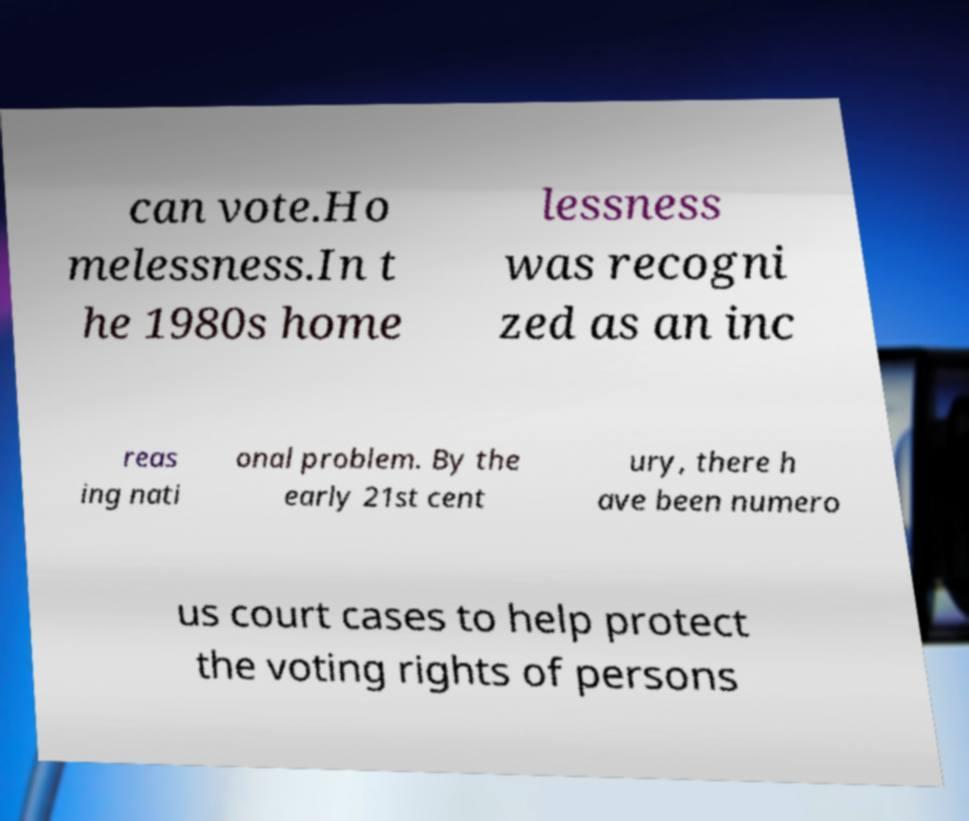There's text embedded in this image that I need extracted. Can you transcribe it verbatim? can vote.Ho melessness.In t he 1980s home lessness was recogni zed as an inc reas ing nati onal problem. By the early 21st cent ury, there h ave been numero us court cases to help protect the voting rights of persons 